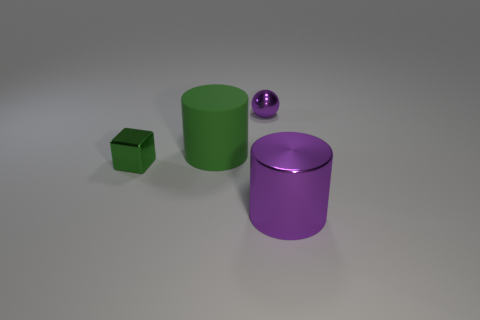Add 1 green objects. How many objects exist? 5 Subtract all cubes. How many objects are left? 3 Add 1 small metallic cubes. How many small metallic cubes exist? 2 Subtract 0 gray cylinders. How many objects are left? 4 Subtract all big brown metal objects. Subtract all purple metal objects. How many objects are left? 2 Add 4 spheres. How many spheres are left? 5 